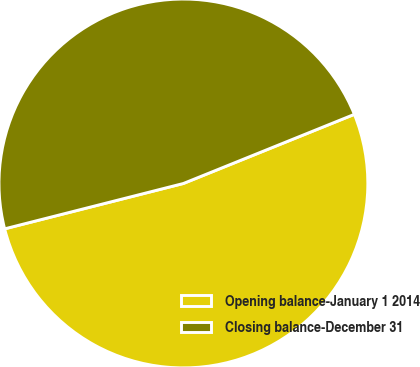Convert chart to OTSL. <chart><loc_0><loc_0><loc_500><loc_500><pie_chart><fcel>Opening balance-January 1 2014<fcel>Closing balance-December 31<nl><fcel>52.16%<fcel>47.84%<nl></chart> 